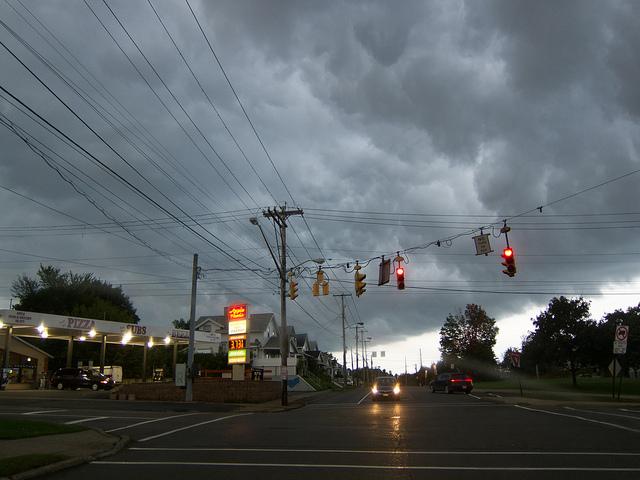What color is the traffic light?
Keep it brief. Red. Is it daytime in the photo?
Keep it brief. Yes. Can a person buy pizza at the gas station?
Concise answer only. Yes. 